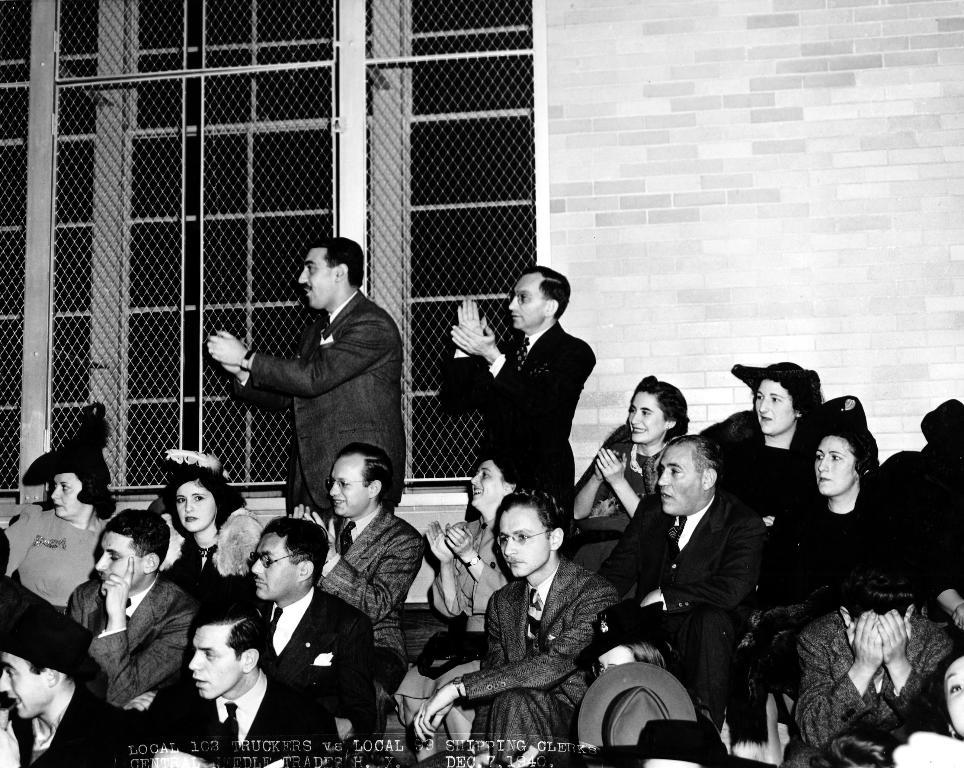What are the people in the image doing? There is a group of people sitting in the image. Are there any other people in the image besides those sitting? Yes, there are two persons standing in the image. What can be seen in the background of the image? There is a wall and windows with mesh in the image. Is there any additional information about the image itself? Yes, there is a watermark at the bottom of the image. What type of cap is the map wearing in the image? There is no map or cap present in the image. Can you tell me how many blades are visible in the image? There are no blades visible in the image. 